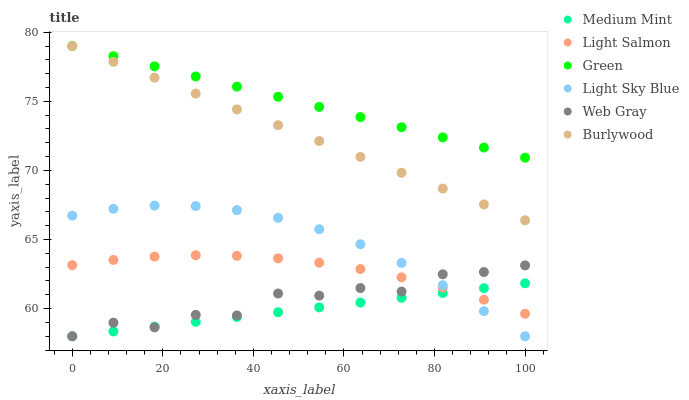Does Medium Mint have the minimum area under the curve?
Answer yes or no. Yes. Does Green have the maximum area under the curve?
Answer yes or no. Yes. Does Light Salmon have the minimum area under the curve?
Answer yes or no. No. Does Light Salmon have the maximum area under the curve?
Answer yes or no. No. Is Burlywood the smoothest?
Answer yes or no. Yes. Is Web Gray the roughest?
Answer yes or no. Yes. Is Light Salmon the smoothest?
Answer yes or no. No. Is Light Salmon the roughest?
Answer yes or no. No. Does Medium Mint have the lowest value?
Answer yes or no. Yes. Does Light Salmon have the lowest value?
Answer yes or no. No. Does Green have the highest value?
Answer yes or no. Yes. Does Light Salmon have the highest value?
Answer yes or no. No. Is Light Sky Blue less than Burlywood?
Answer yes or no. Yes. Is Green greater than Light Sky Blue?
Answer yes or no. Yes. Does Light Sky Blue intersect Web Gray?
Answer yes or no. Yes. Is Light Sky Blue less than Web Gray?
Answer yes or no. No. Is Light Sky Blue greater than Web Gray?
Answer yes or no. No. Does Light Sky Blue intersect Burlywood?
Answer yes or no. No. 